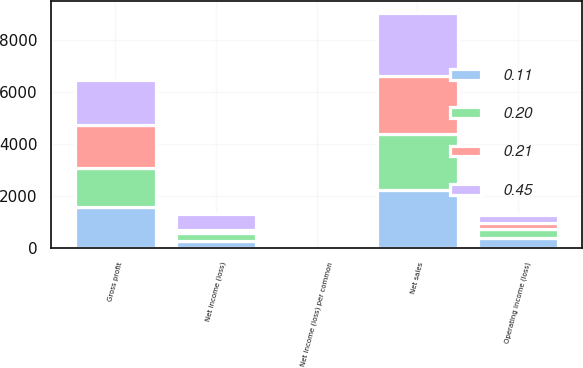Convert chart. <chart><loc_0><loc_0><loc_500><loc_500><stacked_bar_chart><ecel><fcel>Net sales<fcel>Gross profit<fcel>Operating income (loss)<fcel>Net income (loss)<fcel>Net income (loss) per common<nl><fcel>0.2<fcel>2160<fcel>1510<fcel>364<fcel>290<fcel>0.21<nl><fcel>0.21<fcel>2257<fcel>1625<fcel>225<fcel>146<fcel>0.11<nl><fcel>0.11<fcel>2222<fcel>1585<fcel>377<fcel>283<fcel>0.2<nl><fcel>0.45<fcel>2408<fcel>1735<fcel>319<fcel>615<fcel>0.45<nl></chart> 